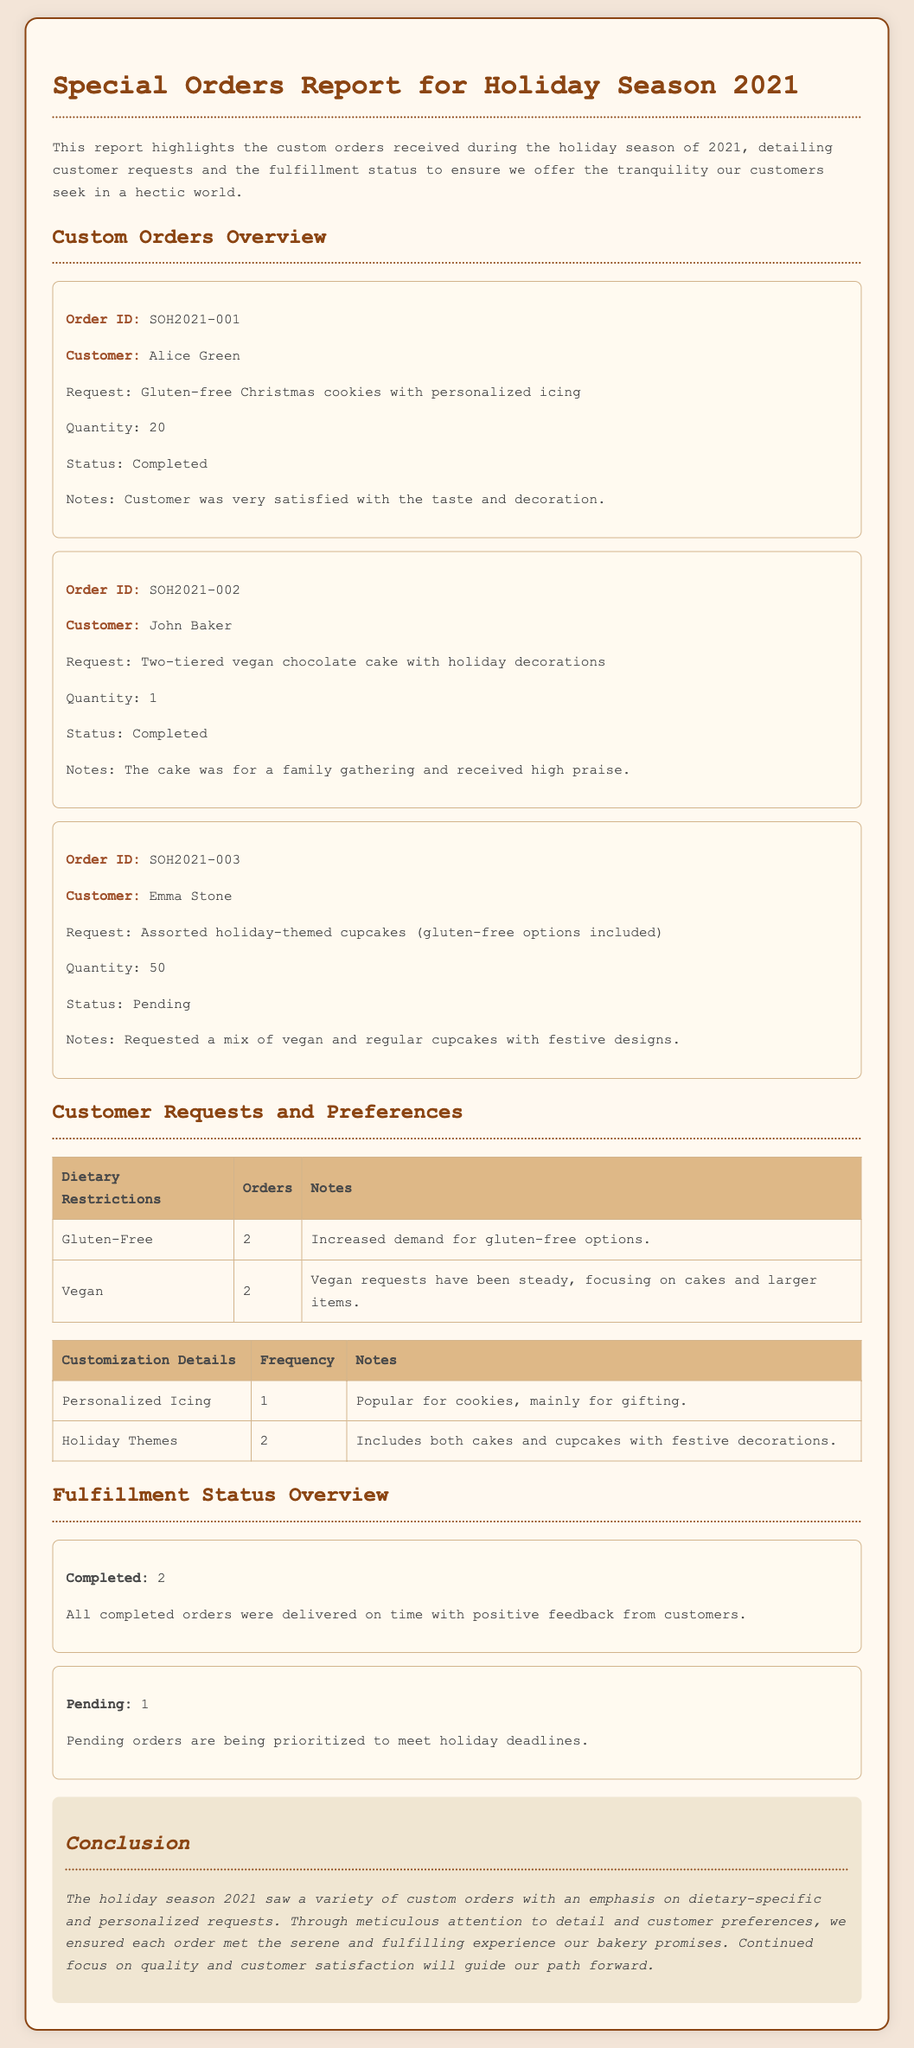What is the first order ID listed? The first order ID mentioned is SOH2021-001, which is the identifier for the order from Alice Green.
Answer: SOH2021-001 How many gluten-free orders were placed? The document specifies that there were 2 gluten-free orders, which reflects increased demand for such options.
Answer: 2 Who is the customer for the second order? The second order is from John Baker, who requested a two-tiered vegan chocolate cake.
Answer: John Baker What is the quantity of assorted holiday-themed cupcakes ordered? The quantity of assorted holiday-themed cupcakes requested by Emma Stone is stated as 50.
Answer: 50 What is the status of the third order? The status of the third order is mentioned as pending, indicating it has not yet been completed.
Answer: Pending How many completed orders were there during the holiday season? There were a total of 2 completed orders, as reported in the fulfillment status overview.
Answer: 2 What customization detail was popular for cookies? The popular customization detail for cookies is personalized icing, specifically mentioned for gifting.
Answer: Personalized Icing How many vegan requests were noted in the document? The document notes a steady demand for 2 vegan requests, particularly focusing on cakes and larger items.
Answer: 2 What is stated about the pending orders? The document mentions that pending orders are being prioritized to meet holiday deadlines.
Answer: Prioritized 